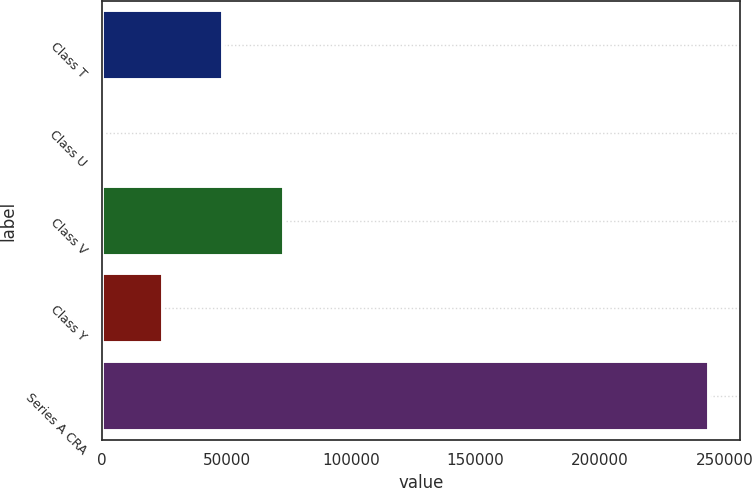Convert chart to OTSL. <chart><loc_0><loc_0><loc_500><loc_500><bar_chart><fcel>Class T<fcel>Class U<fcel>Class V<fcel>Class Y<fcel>Series A CRA<nl><fcel>48764.2<fcel>1.94<fcel>73145.3<fcel>24383<fcel>243813<nl></chart> 